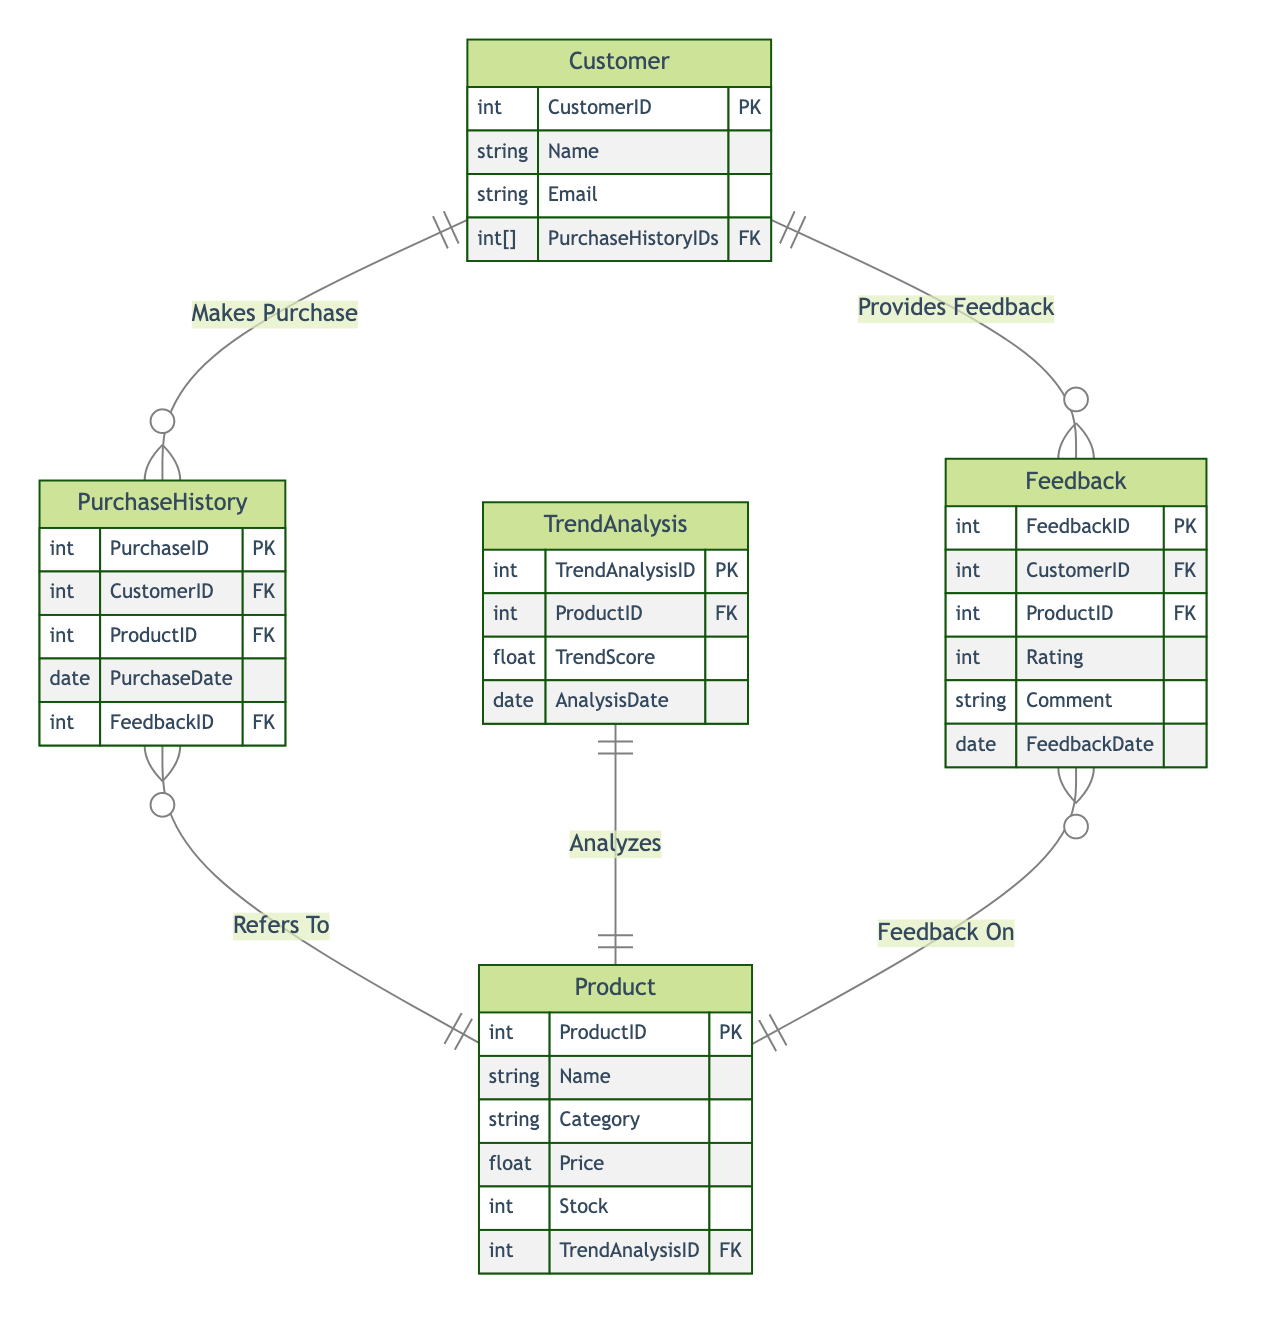what is the primary key of the Customer entity? The primary key (PK) for the Customer entity is CustomerID, which uniquely identifies each customer in the system.
Answer: CustomerID how many entities are in the diagram? By counting the different entities listed, there are five entities: Customer, PurchaseHistory, Product, Feedback, and TrendAnalysis.
Answer: 5 what relationship exists between the Feedback and Product entities? The diagram shows a "Feedback On" relationship between the Feedback and Product entities, indicating that feedback is provided for specific products.
Answer: Feedback On which entity is analyzed by TrendAnalysis? The TrendAnalysis entity has a one-to-one relationship with the Product entity, indicating each trend analysis directly correlates with one specific product.
Answer: Product how many attributes does the Product entity have? The Product entity has six attributes: ProductID, Name, Category, Price, Stock, and TrendAnalysisID.
Answer: 6 which entity is responsible for providing ratings? The Feedback entity is responsible for providing ratings, as it contains the Rating attribute that allows customers to rate products.
Answer: Feedback what is the foreign key in the PurchaseHistory entity? In the PurchaseHistory entity, the foreign keys are CustomerID and ProductID, which refer to the Customer and Product entities, respectively, linking purchases to customers and products.
Answer: CustomerID, ProductID which entity links customer feedback directly to products? The Feedback entity acts as a link that connects customer feedback directly to the Product entity through the "Feedback On" relationship.
Answer: Feedback 